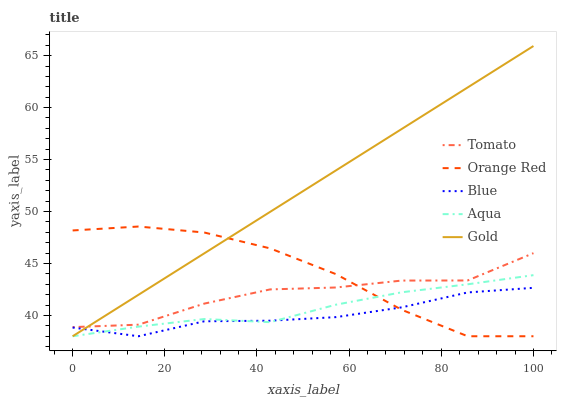Does Blue have the minimum area under the curve?
Answer yes or no. Yes. Does Gold have the maximum area under the curve?
Answer yes or no. Yes. Does Aqua have the minimum area under the curve?
Answer yes or no. No. Does Aqua have the maximum area under the curve?
Answer yes or no. No. Is Gold the smoothest?
Answer yes or no. Yes. Is Tomato the roughest?
Answer yes or no. Yes. Is Blue the smoothest?
Answer yes or no. No. Is Blue the roughest?
Answer yes or no. No. Does Blue have the lowest value?
Answer yes or no. Yes. Does Gold have the highest value?
Answer yes or no. Yes. Does Aqua have the highest value?
Answer yes or no. No. Is Aqua less than Tomato?
Answer yes or no. Yes. Is Tomato greater than Blue?
Answer yes or no. Yes. Does Orange Red intersect Aqua?
Answer yes or no. Yes. Is Orange Red less than Aqua?
Answer yes or no. No. Is Orange Red greater than Aqua?
Answer yes or no. No. Does Aqua intersect Tomato?
Answer yes or no. No. 